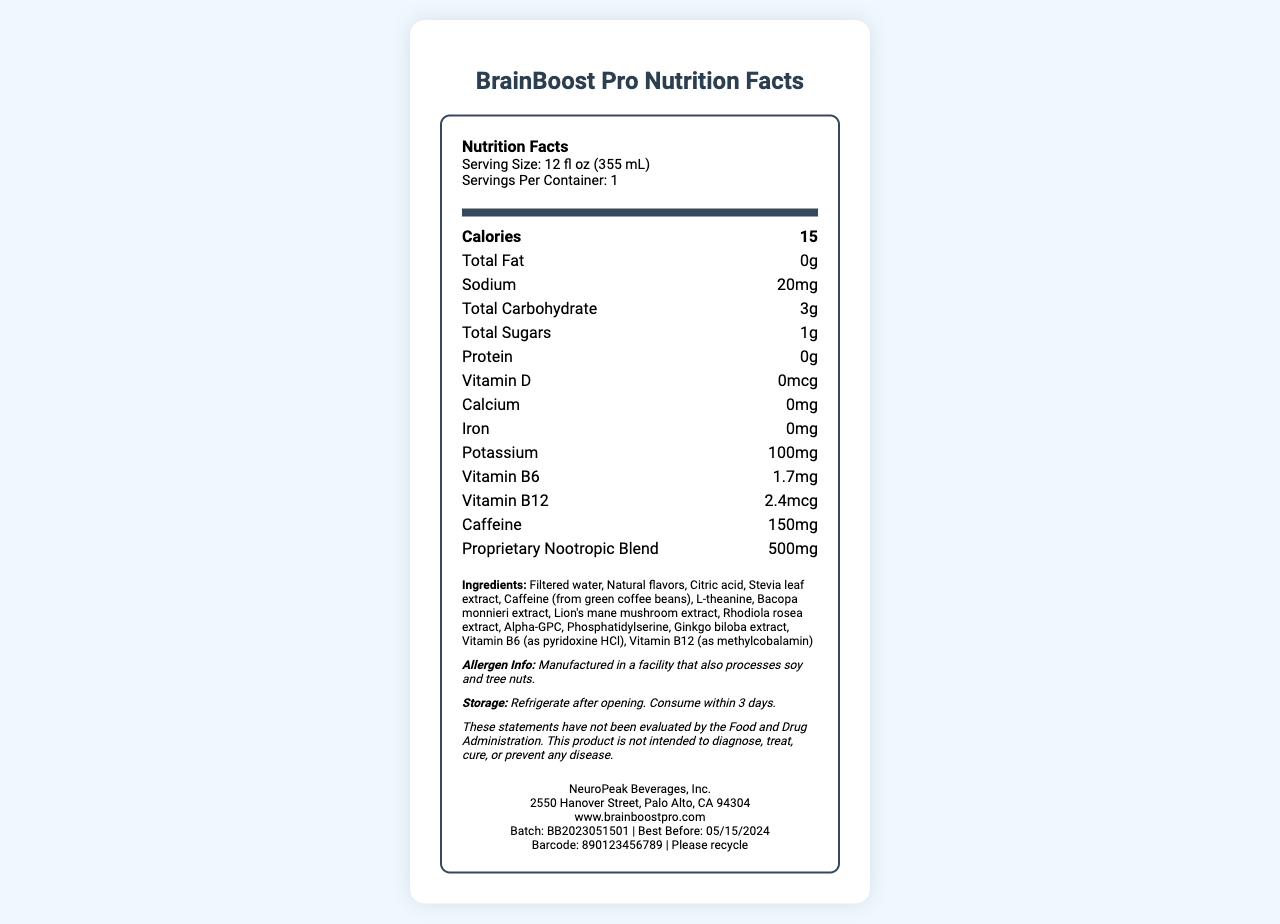what is the serving size of BrainBoost Pro? The serving size is listed at the beginning under serving info: "Serving Size: 12 fl oz (355 mL)."
Answer: 12 fl oz (355 mL) How many calories are in one serving? The calories per serving are shown directly under the "Calories" heading.
Answer: 15 What is the total carbohydrate content in BrainBoost Pro? The total carbohydrate content is listed in the nutrient row: "Total Carbohydrate: 3g."
Answer: 3g List three main ingredients in BrainBoost Pro. The ingredients are listed in the ingredients section: "Filtered water, Natural flavors, Citric acid..."
Answer: Filtered water, Natural flavors, Citric acid What is the amount of caffeine in BrainBoost Pro? The caffeine content is listed in the nutrient row: "Caffeine: 150mg."
Answer: 150mg What is the proprietary nootropic blend amount in BrainBoost Pro? The proprietary nootropic blend amount is specified: "Proprietary Nootropic Blend: 500mg."
Answer: 500mg Who is the manufacturer of BrainBoost Pro? A. BrainBoost Inc B. NeuroPeak Beverages, Inc. C. Cognitive Enhancers Corp The manufacturer is listed at the bottom of the document: "NeuroPeak Beverages, Inc."
Answer: B What is the best before date for this product? I. 04/15/2024 II. 05/15/2024 III. 06/15/2024 The best before date is listed near the bottom: "Best Before: 05/15/2024."
Answer: II Is the information about the product's allergen processed in a facility that also processes dairy? The allergen information specifically states: "Manufactured in a facility that also processes soy and tree nuts."
Answer: No Briefly summarize the key information found in the BrainBoost Pro Nutrition Facts document. The summary covers essential aspects including serving size, calorie content, caffeine amount, proprietary nootropic blend, main ingredients, manufacturer, allergen info, and storage.
Answer: BrainBoost Pro is a nootropic-infused beverage with a serving size of 12 fl oz. It contains minimal calories and carbs but includes a significant amount of caffeine (150mg) and a proprietary nootropic blend (500mg). The main ingredients include filtered water, natural flavors, and several nootropic substances like L-theanine and Bacopa monnieri extract. Produced by NeuroPeak Beverages, Inc., it comes with a specific allergen notice and storage instructions. Which of the following ingredients are not listed in BrainBoost Pro? A. Ginkgo biloba extract B. Bacopa monnieri extract C. Omega-3 fatty acids The ingredient list includes "Ginkgo biloba extract" and "Bacopa monnieri extract," but not "Omega-3 fatty acids."
Answer: C What is the significance of the disclaimer on the BrainBoost Pro label? While the disclaimer states that the product has not been evaluated by the Food and Drug Administration and is not intended to diagnose, treat, cure, or prevent any disease, specific implications or reasons for the disclaimer are not provided.
Answer: Not enough information What is the sodium content per serving? The sodium content is listed in the nutrient row: "Sodium: 20mg."
Answer: 20mg 